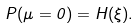Convert formula to latex. <formula><loc_0><loc_0><loc_500><loc_500>P ( \mu = 0 ) = H ( \xi ) .</formula> 